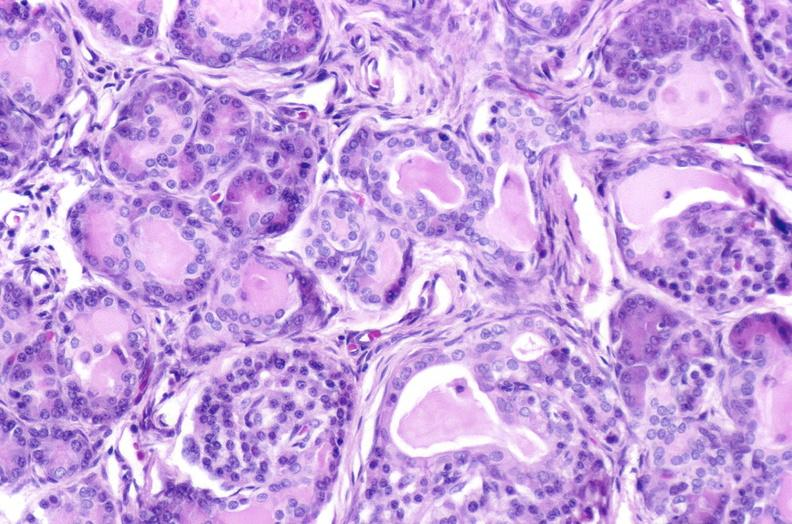s pancreas present?
Answer the question using a single word or phrase. Yes 